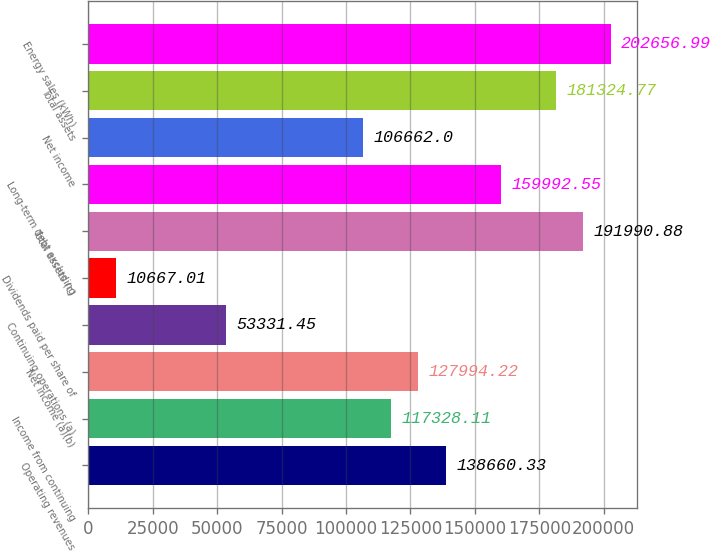<chart> <loc_0><loc_0><loc_500><loc_500><bar_chart><fcel>Operating revenues<fcel>Income from continuing<fcel>Net income (a)(b)<fcel>Continuing operations (a)<fcel>Dividends paid per share of<fcel>Total assets (c)<fcel>Long-term debt excluding<fcel>Net income<fcel>Total assets<fcel>Energy sales (kWh)<nl><fcel>138660<fcel>117328<fcel>127994<fcel>53331.4<fcel>10667<fcel>191991<fcel>159993<fcel>106662<fcel>181325<fcel>202657<nl></chart> 